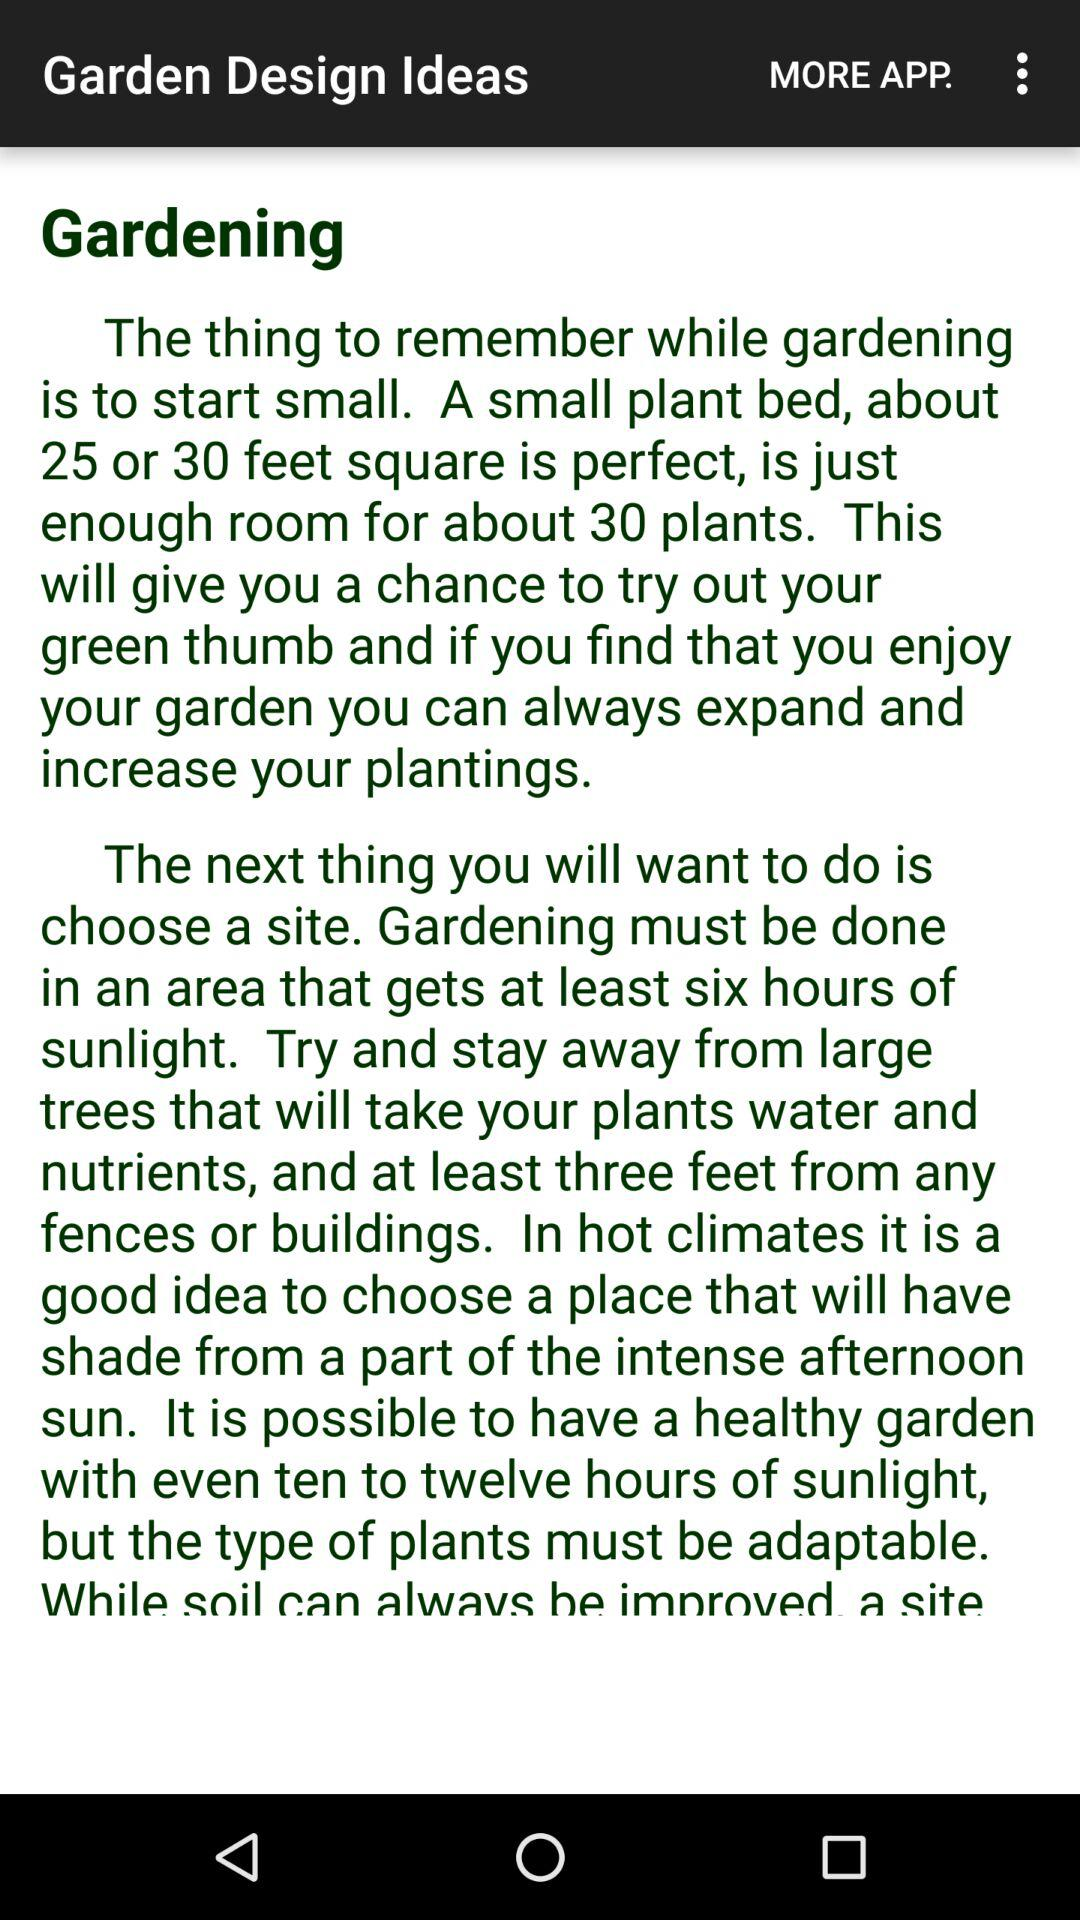What is the name of the application? The name of the application is "Garden Design Ideas". 